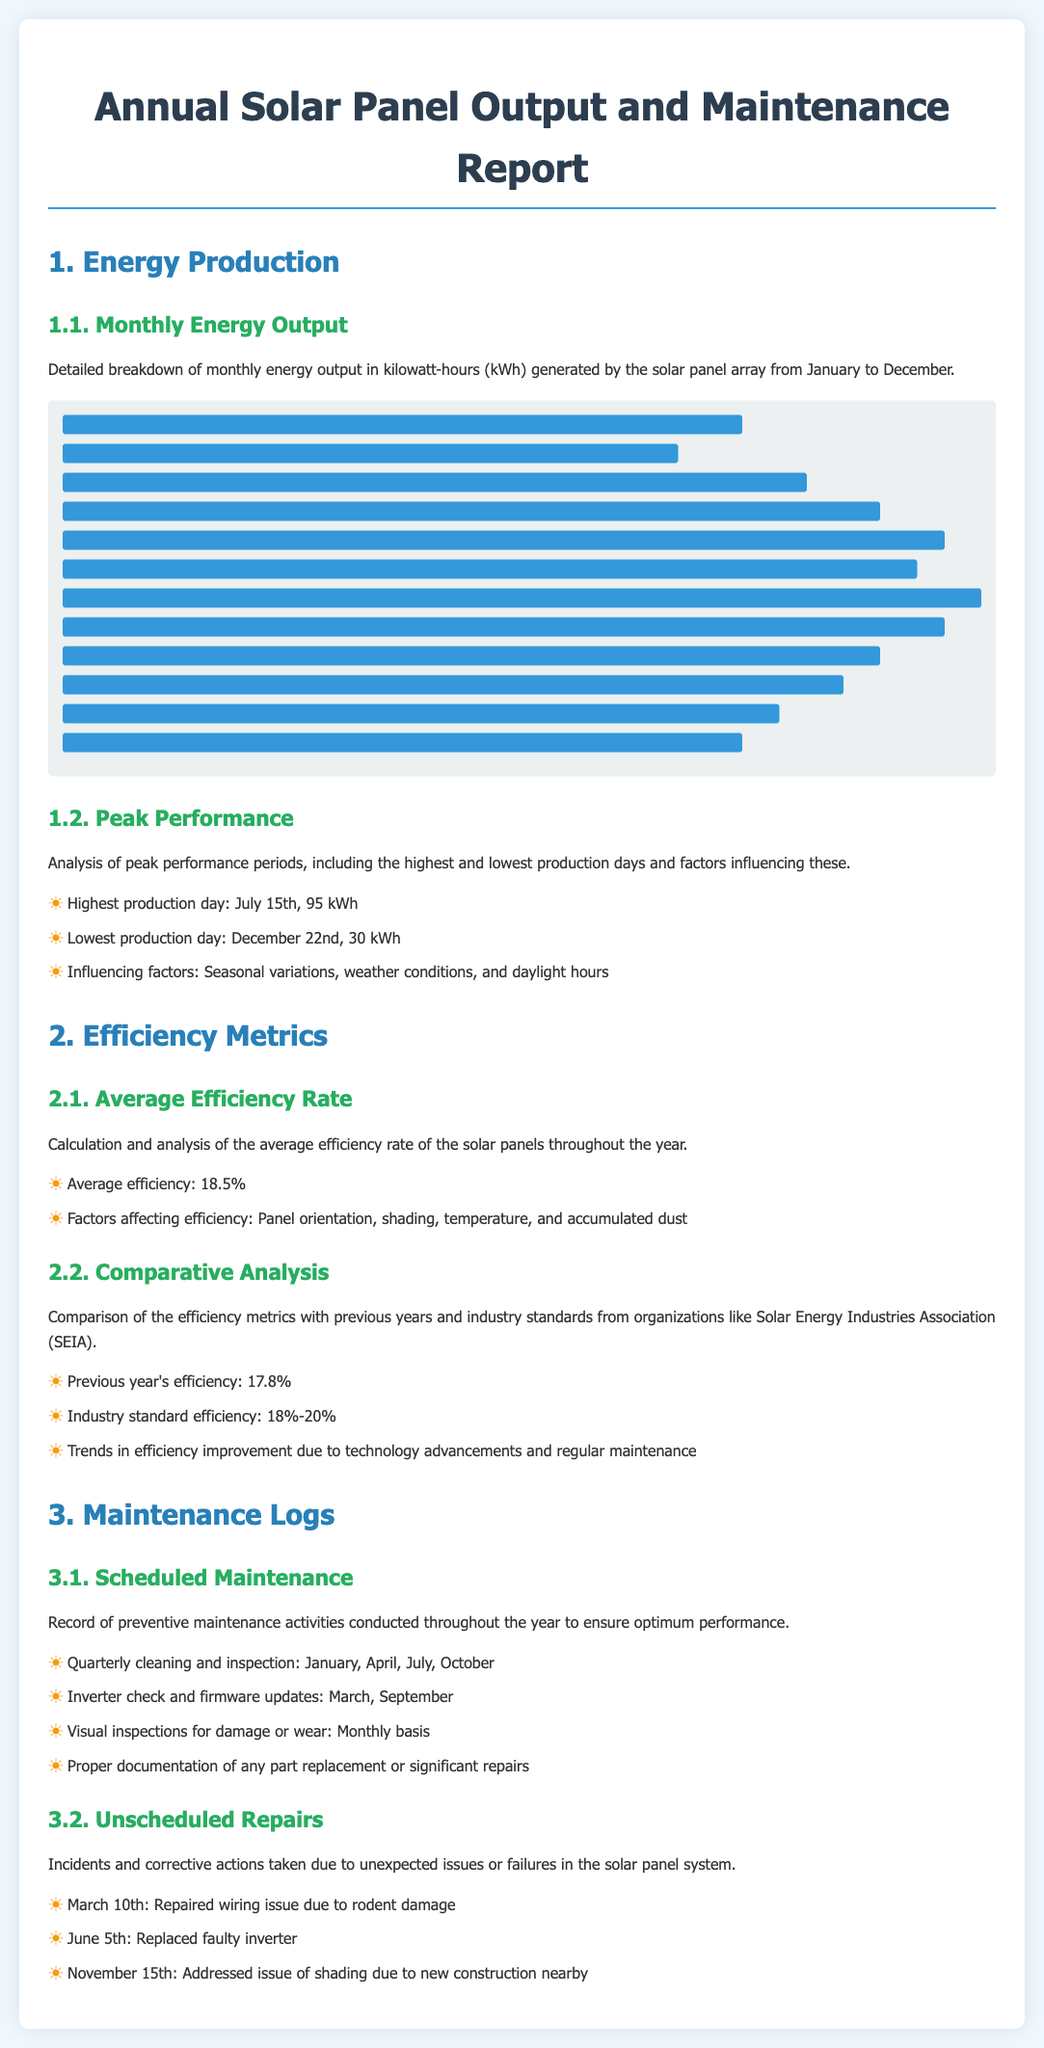What was the total energy output in July? The document states the energy output for July as 2700 kWh.
Answer: 2700 kWh What is the average efficiency of the solar panels? The average efficiency rate of the solar panels throughout the year is 18.5%.
Answer: 18.5% When was the highest production day recorded? The highest production day mentioned in the document is July 15th.
Answer: July 15th What maintenance was performed in January? The document indicates that a quarterly cleaning and inspection was conducted in January.
Answer: Quarterly cleaning and inspection How does the average efficiency of this year compare to last year? The previous year's efficiency was 17.8%, which allows for a comparison with the current year's efficiency.
Answer: Increased What amount of energy was produced in December? The energy output for December recorded in the document is 2000 kWh.
Answer: 2000 kWh What significant repair was made on June 5th? The document notes that a faulty inverter was replaced on June 5th.
Answer: Replaced faulty inverter What were the monthly visual inspections conducted for? The document specifies that visual inspections for damage or wear were carried out on a monthly basis.
Answer: Damage or wear 